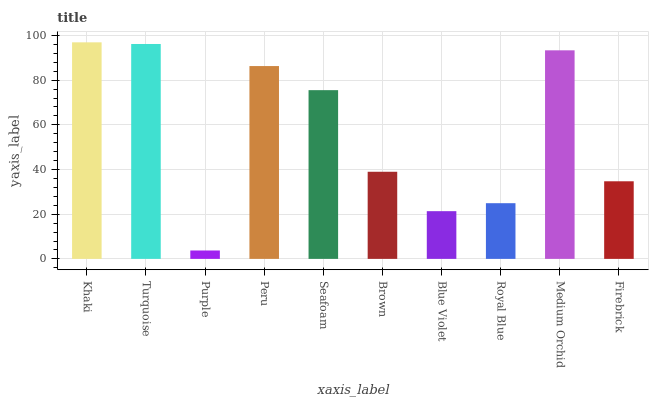Is Purple the minimum?
Answer yes or no. Yes. Is Khaki the maximum?
Answer yes or no. Yes. Is Turquoise the minimum?
Answer yes or no. No. Is Turquoise the maximum?
Answer yes or no. No. Is Khaki greater than Turquoise?
Answer yes or no. Yes. Is Turquoise less than Khaki?
Answer yes or no. Yes. Is Turquoise greater than Khaki?
Answer yes or no. No. Is Khaki less than Turquoise?
Answer yes or no. No. Is Seafoam the high median?
Answer yes or no. Yes. Is Brown the low median?
Answer yes or no. Yes. Is Firebrick the high median?
Answer yes or no. No. Is Purple the low median?
Answer yes or no. No. 